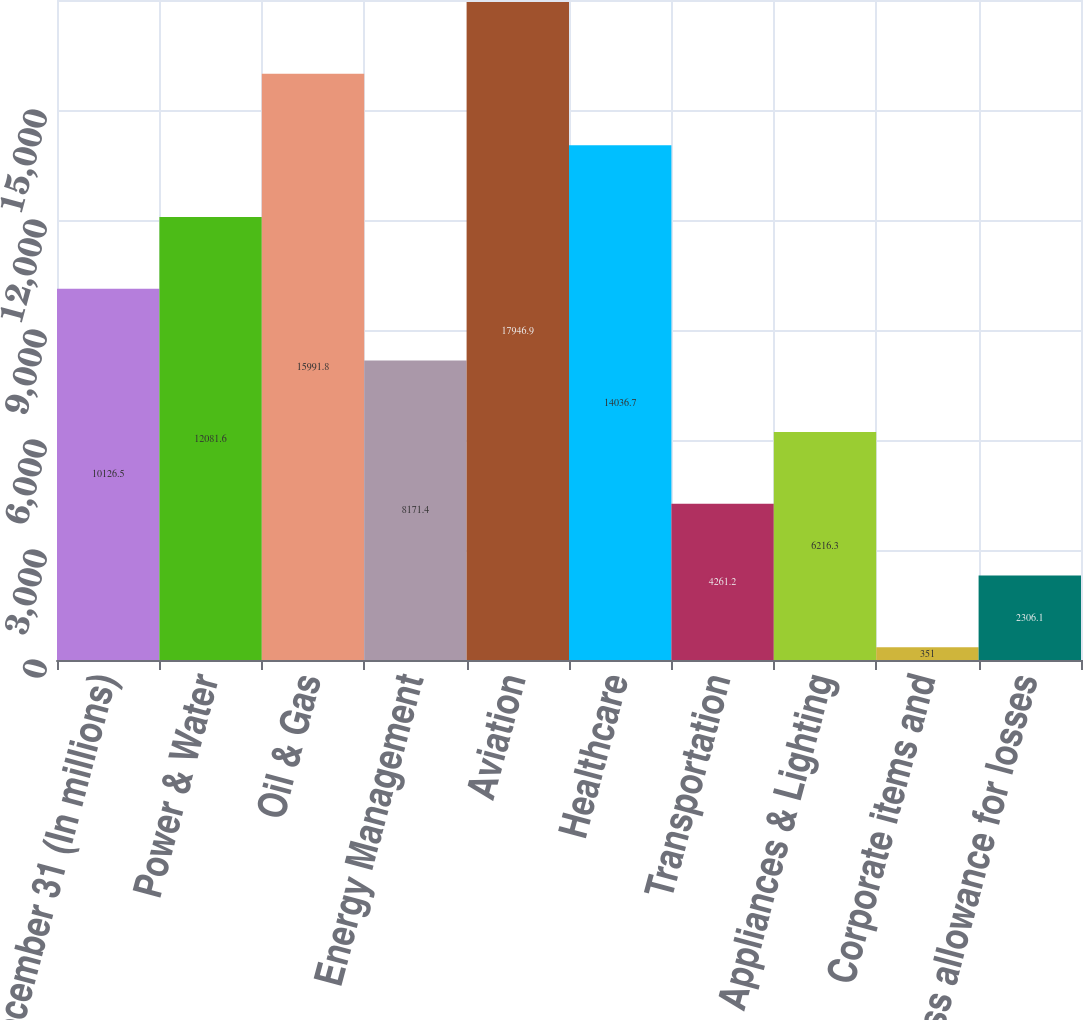Convert chart. <chart><loc_0><loc_0><loc_500><loc_500><bar_chart><fcel>December 31 (In millions)<fcel>Power & Water<fcel>Oil & Gas<fcel>Energy Management<fcel>Aviation<fcel>Healthcare<fcel>Transportation<fcel>Appliances & Lighting<fcel>Corporate items and<fcel>Less allowance for losses<nl><fcel>10126.5<fcel>12081.6<fcel>15991.8<fcel>8171.4<fcel>17946.9<fcel>14036.7<fcel>4261.2<fcel>6216.3<fcel>351<fcel>2306.1<nl></chart> 